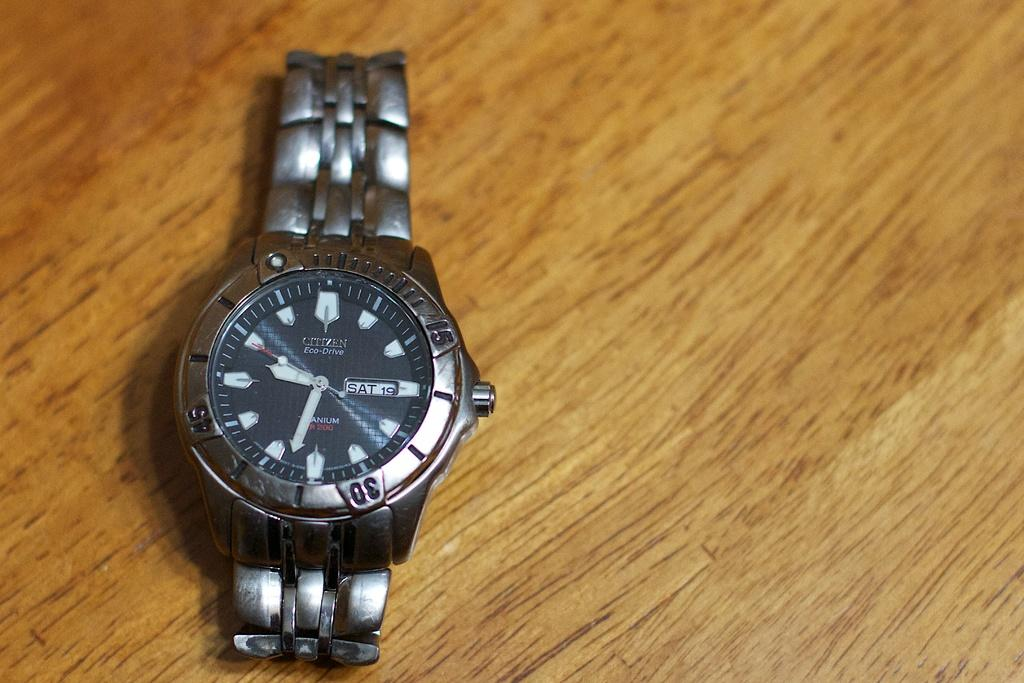<image>
Summarize the visual content of the image. A silver and black Citizen wrist watch showing a little passed 9:30. 